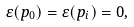<formula> <loc_0><loc_0><loc_500><loc_500>\varepsilon ( p _ { 0 } ) = \varepsilon ( p _ { i } ) = 0 ,</formula> 